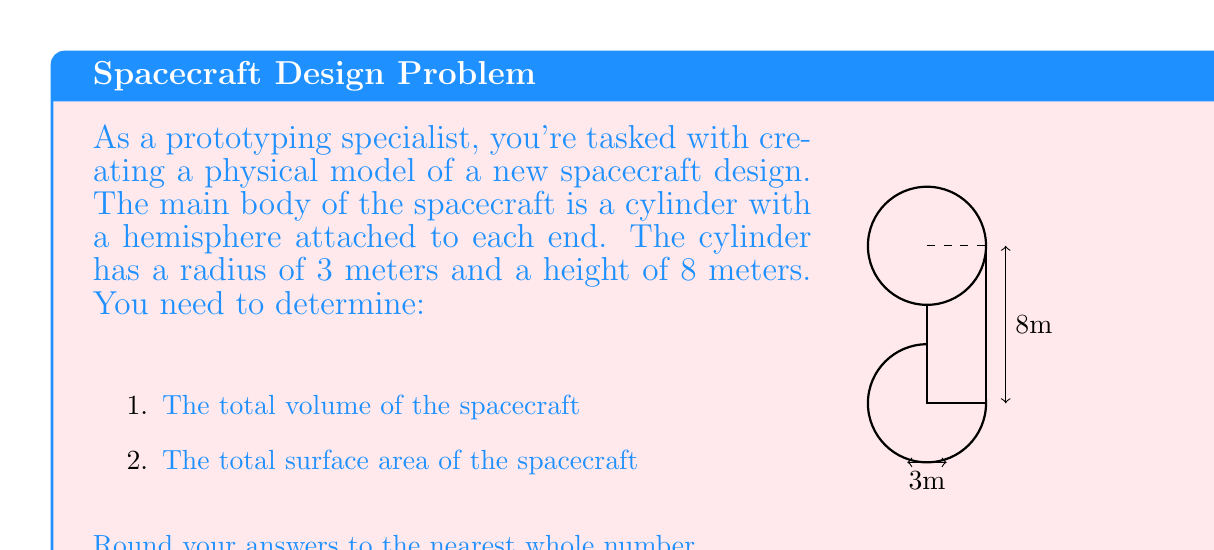Can you solve this math problem? Let's approach this step-by-step:

1) Volume calculation:
   a) Volume of cylinder: $V_c = \pi r^2 h$
      $V_c = \pi \cdot 3^2 \cdot 8 = 72\pi$ cubic meters
   
   b) Volume of each hemisphere: $V_h = \frac{2}{3}\pi r^3$
      $V_h = \frac{2}{3}\pi \cdot 3^3 = 18\pi$ cubic meters
   
   c) Total volume: $V_{total} = V_c + 2V_h$
      $V_{total} = 72\pi + 2(18\pi) = 108\pi \approx 339$ cubic meters

2) Surface area calculation:
   a) Lateral surface area of cylinder: $A_l = 2\pi r h$
      $A_l = 2\pi \cdot 3 \cdot 8 = 48\pi$ square meters
   
   b) Surface area of each hemisphere: $A_h = 2\pi r^2$
      $A_h = 2\pi \cdot 3^2 = 18\pi$ square meters
   
   c) Total surface area: $A_{total} = A_l + 2A_h$
      $A_{total} = 48\pi + 2(18\pi) = 84\pi \approx 264$ square meters
Answer: Volume: 339 m³, Surface Area: 264 m² 